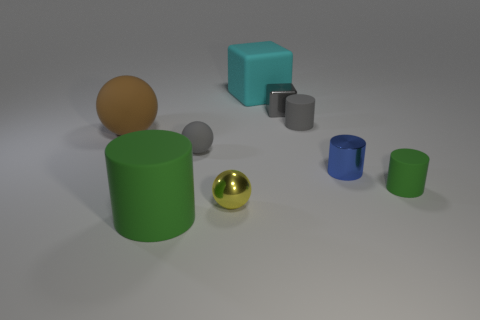There is a tiny thing that is the same color as the big cylinder; what is it made of?
Provide a short and direct response. Rubber. How many matte things are the same color as the metallic block?
Provide a succinct answer. 2. What shape is the gray thing that is left of the cyan rubber object?
Keep it short and to the point. Sphere. What size is the other cylinder that is the same color as the large cylinder?
Your response must be concise. Small. Is there a yellow sphere that has the same size as the cyan block?
Keep it short and to the point. No. Do the big thing that is behind the small cube and the tiny blue cylinder have the same material?
Ensure brevity in your answer.  No. Are there the same number of tiny blue shiny cylinders that are behind the gray metallic object and big cyan blocks left of the big rubber cylinder?
Offer a terse response. Yes. What shape is the large thing that is both to the left of the shiny ball and behind the tiny gray sphere?
Offer a terse response. Sphere. How many tiny gray shiny things are in front of the tiny green cylinder?
Your response must be concise. 0. What number of other things are the same shape as the small yellow metal object?
Your answer should be compact. 2. 